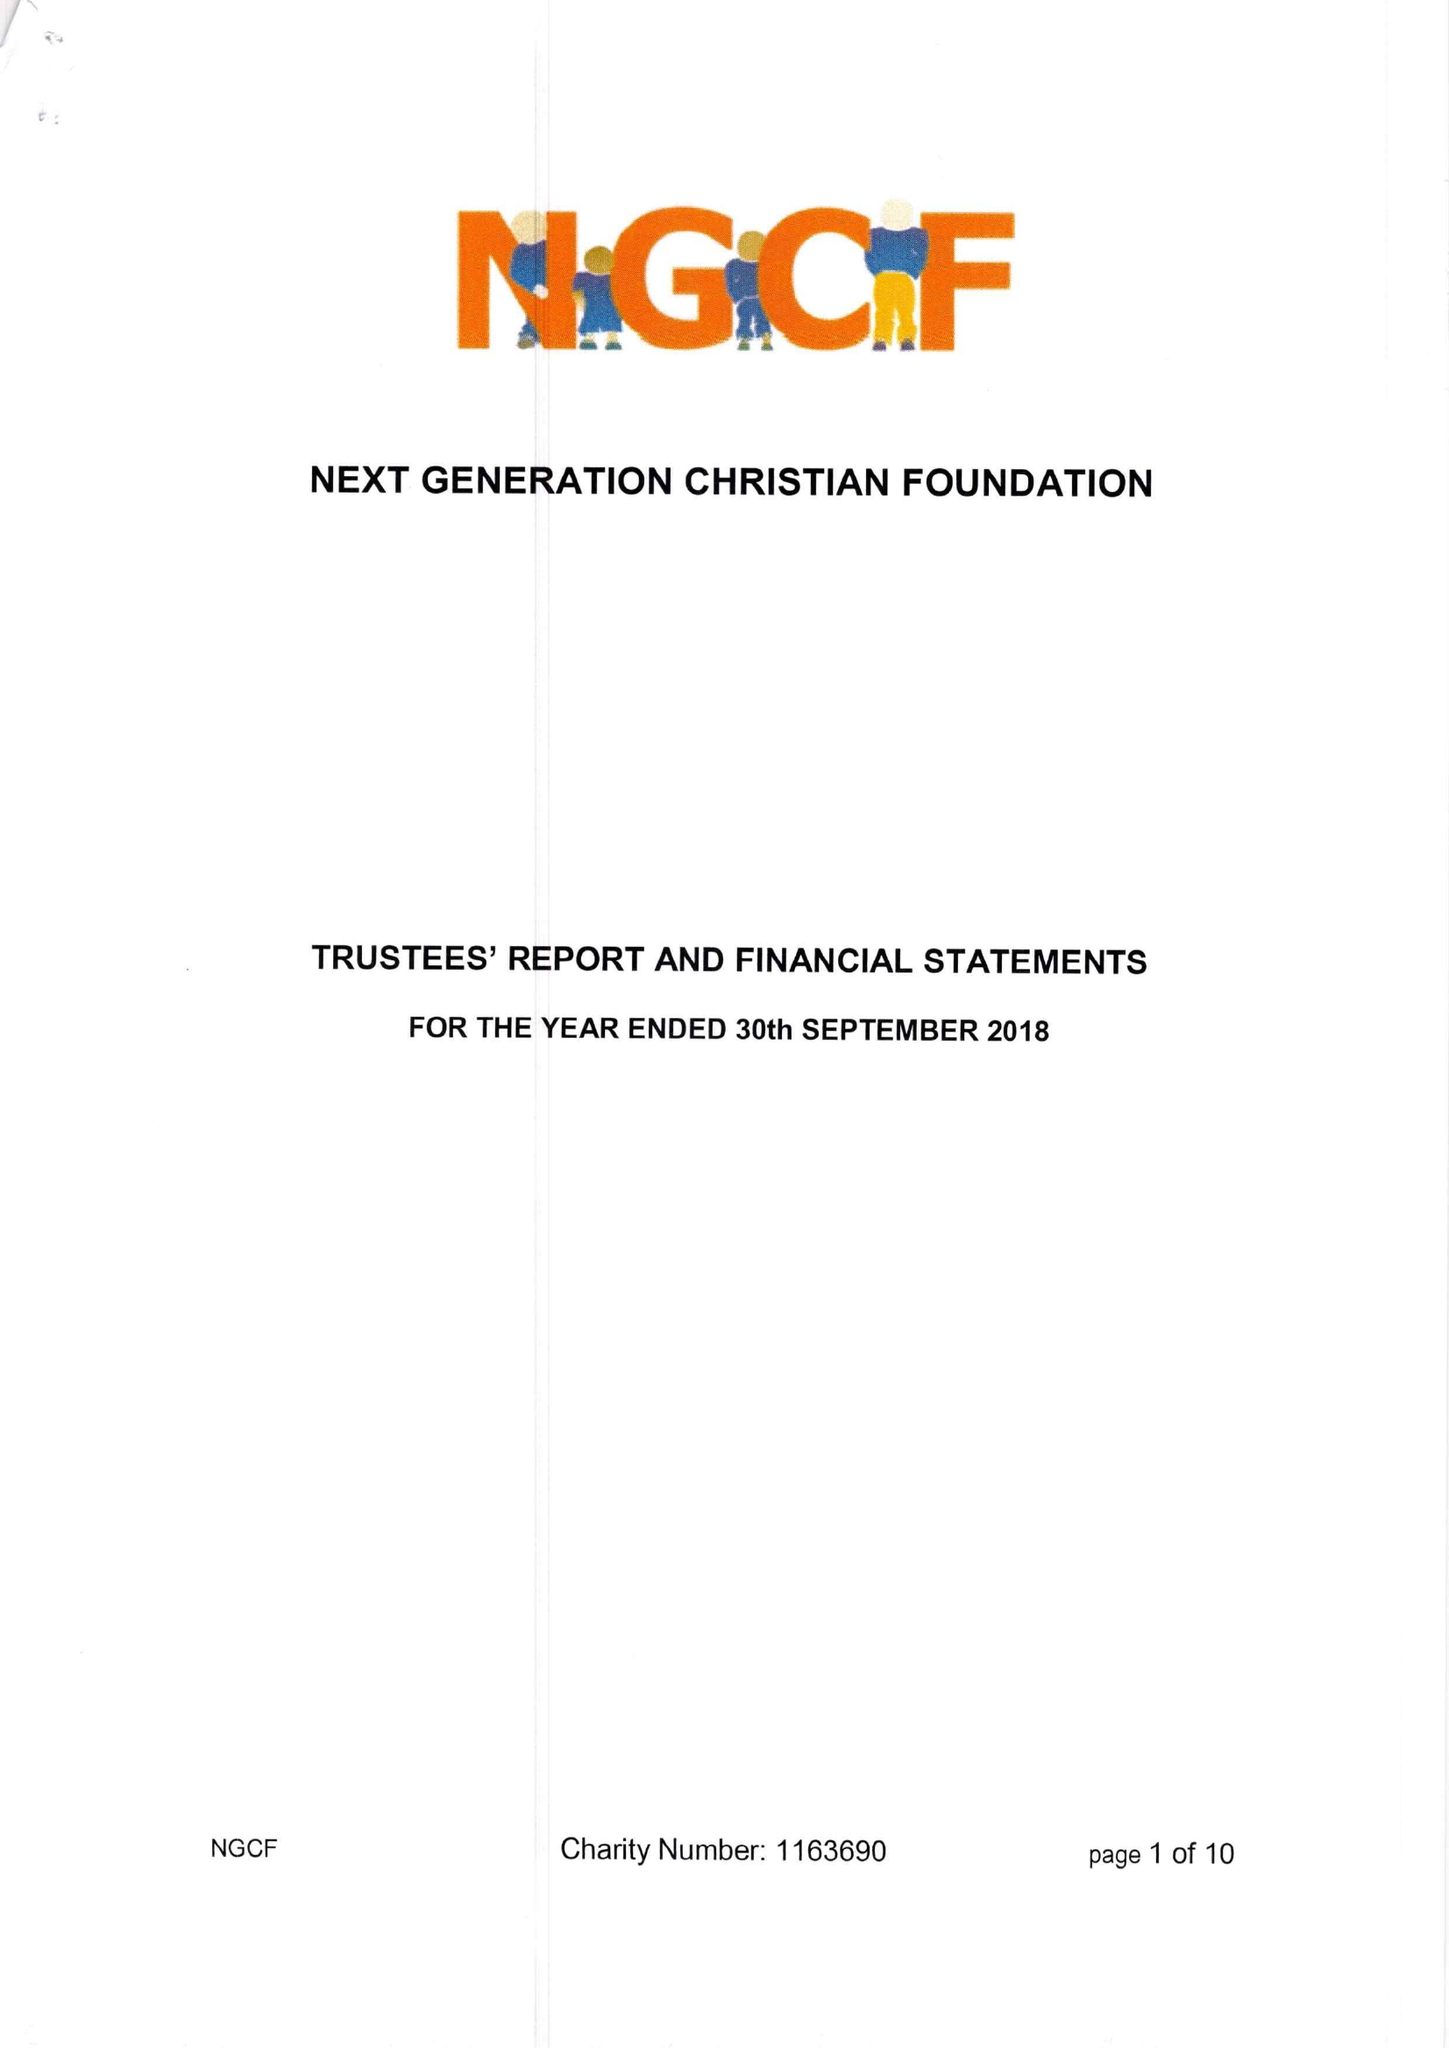What is the value for the address__street_line?
Answer the question using a single word or phrase. None 